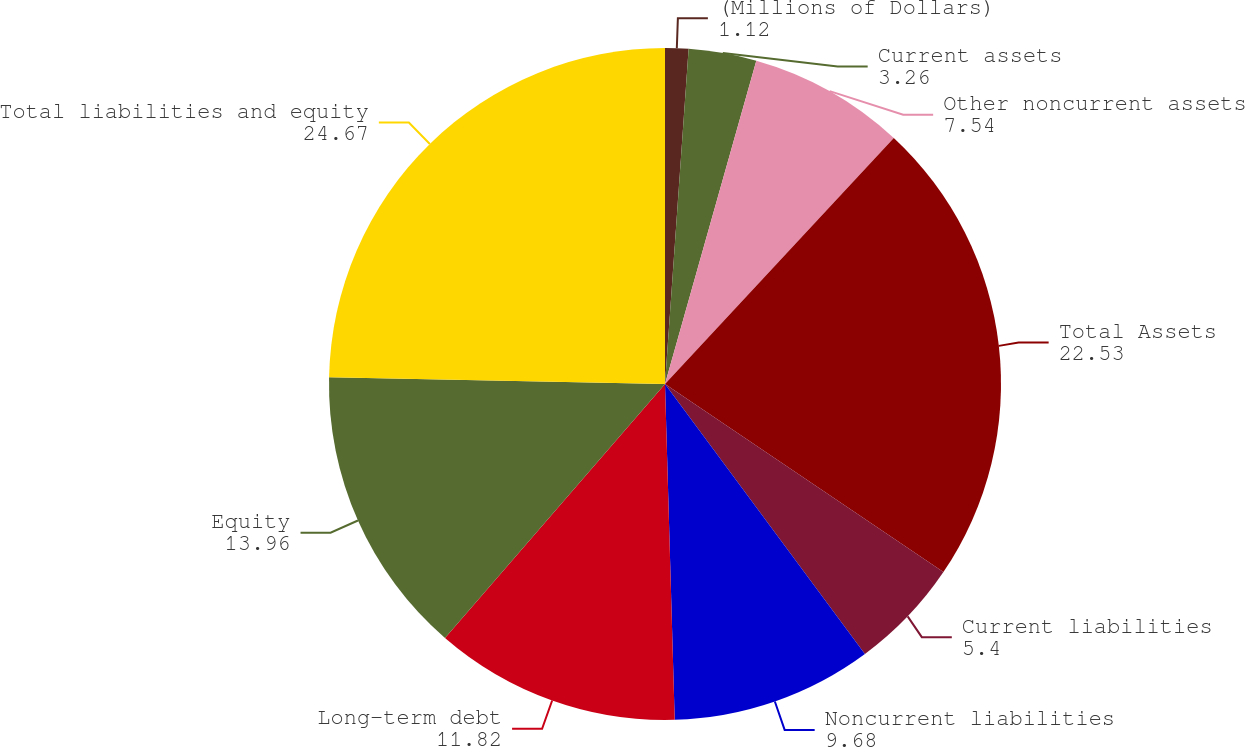<chart> <loc_0><loc_0><loc_500><loc_500><pie_chart><fcel>(Millions of Dollars)<fcel>Current assets<fcel>Other noncurrent assets<fcel>Total Assets<fcel>Current liabilities<fcel>Noncurrent liabilities<fcel>Long-term debt<fcel>Equity<fcel>Total liabilities and equity<nl><fcel>1.12%<fcel>3.26%<fcel>7.54%<fcel>22.53%<fcel>5.4%<fcel>9.68%<fcel>11.82%<fcel>13.96%<fcel>24.67%<nl></chart> 